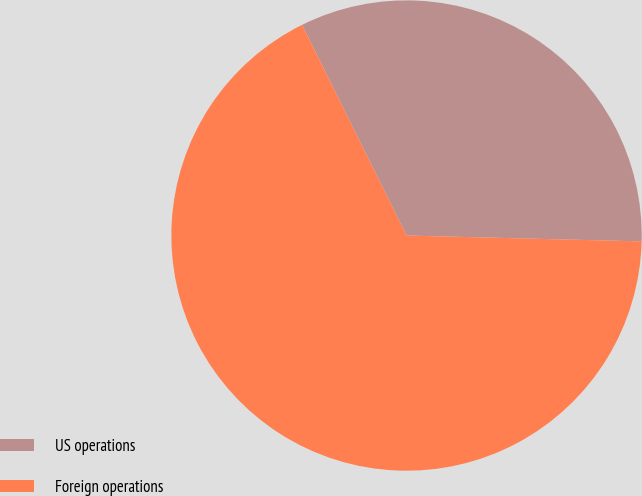<chart> <loc_0><loc_0><loc_500><loc_500><pie_chart><fcel>US operations<fcel>Foreign operations<nl><fcel>32.72%<fcel>67.28%<nl></chart> 